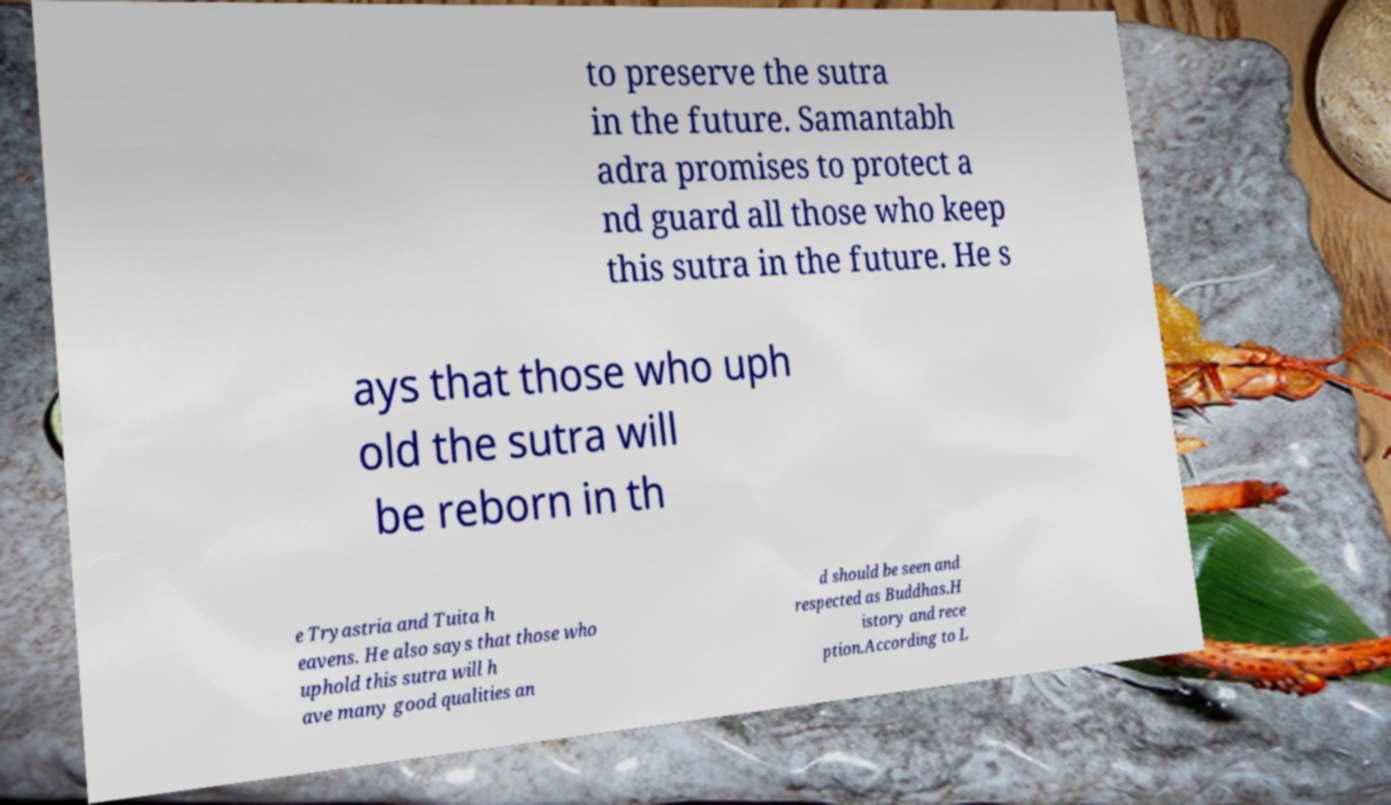I need the written content from this picture converted into text. Can you do that? to preserve the sutra in the future. Samantabh adra promises to protect a nd guard all those who keep this sutra in the future. He s ays that those who uph old the sutra will be reborn in th e Tryastria and Tuita h eavens. He also says that those who uphold this sutra will h ave many good qualities an d should be seen and respected as Buddhas.H istory and rece ption.According to L 